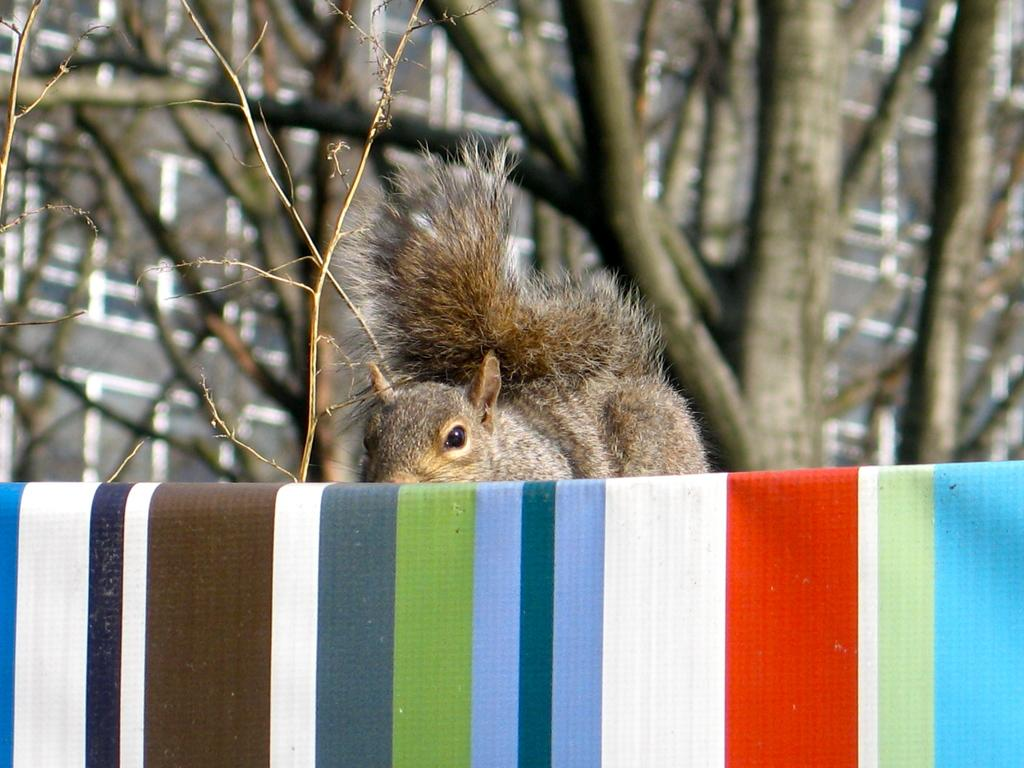What type of animal can be seen in the image? There is a squirrel in the image. What is the colorful object at the bottom of the image? Unfortunately, the facts provided do not give any information about the colorful object at the bottom of the image. What can be seen in the background of the image? There is a tree in the background of the image. What type of letter is the squirrel holding in the image? There is no letter present in the image; it features a squirrel and a tree in the background. 